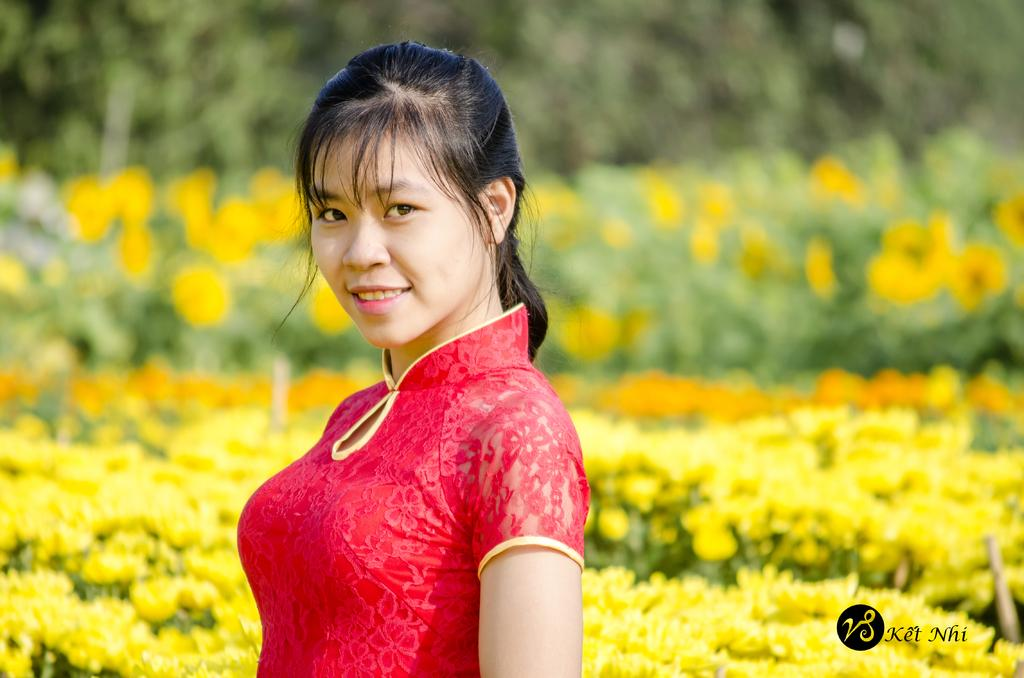What is the main subject of the image? There is a woman standing in the middle of the image. What is the woman doing in the image? The woman is smiling in the image. What can be seen behind the woman? There are flowers and plants behind the woman. How would you describe the background of the image? The background of the image is blurred. Can you tell me how many windows are visible in the image? There are no windows visible in the image; it features a woman standing in front of flowers and plants. What type of face is shown on the woman's face in the image? The woman's face is not shown in the image, only her smile is visible. 